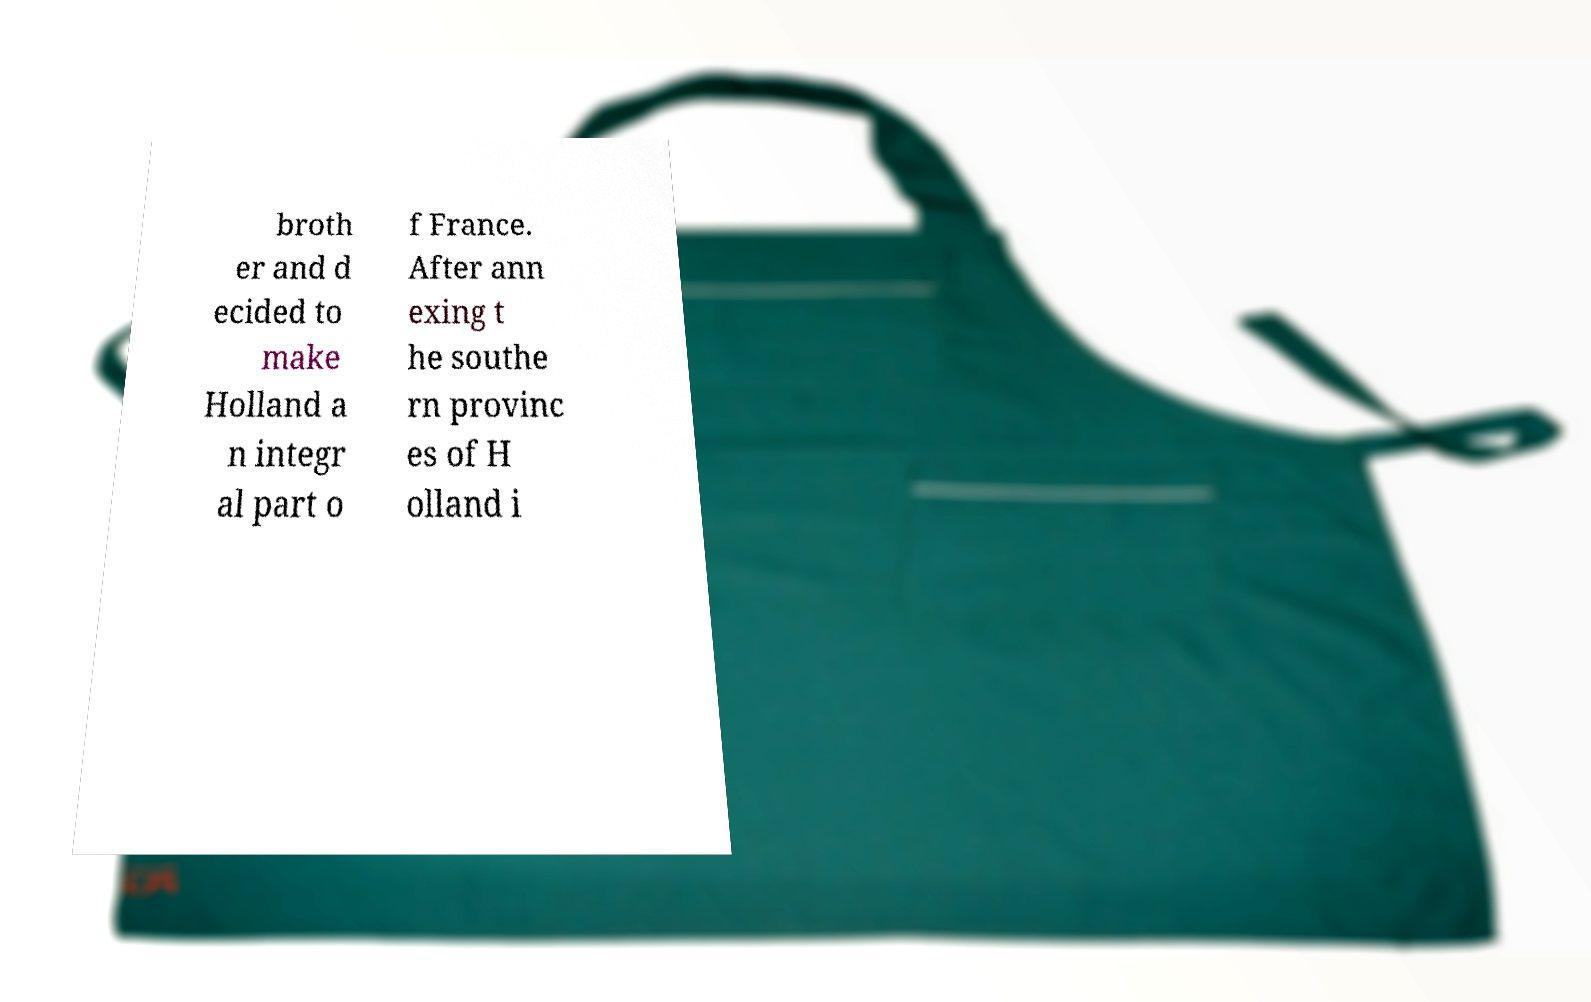What messages or text are displayed in this image? I need them in a readable, typed format. broth er and d ecided to make Holland a n integr al part o f France. After ann exing t he southe rn provinc es of H olland i 